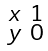<formula> <loc_0><loc_0><loc_500><loc_500>\begin{smallmatrix} x & 1 \\ y & 0 \end{smallmatrix}</formula> 